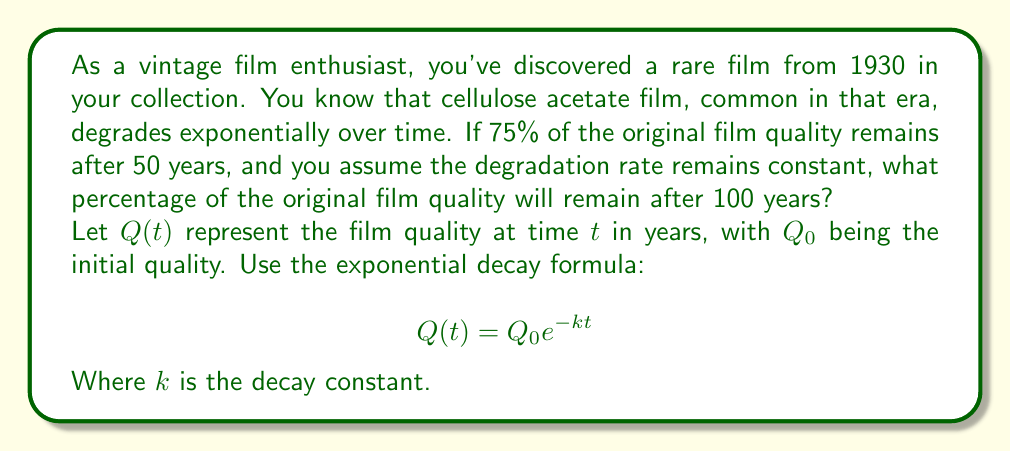Teach me how to tackle this problem. To solve this problem, we'll follow these steps:

1) First, we need to find the decay constant $k$ using the given information:
   After 50 years, 75% of the original quality remains.
   
   $$0.75Q_0 = Q_0 e^{-k(50)}$$

2) Divide both sides by $Q_0$:
   
   $$0.75 = e^{-50k}$$

3) Take the natural logarithm of both sides:
   
   $$\ln(0.75) = -50k$$

4) Solve for $k$:
   
   $$k = -\frac{\ln(0.75)}{50} \approx 0.005755$$

5) Now that we have $k$, we can use the exponential decay formula to find the quality after 100 years:
   
   $$Q(100) = Q_0 e^{-k(100)}$$

6) Substitute $k = 0.005755$:
   
   $$Q(100) = Q_0 e^{-0.005755(100)}$$

7) Simplify:
   
   $$Q(100) = Q_0 e^{-0.5755} \approx 0.5625Q_0$$

8) Convert to a percentage:
   
   $0.5625 * 100\% = 56.25\%$

Therefore, after 100 years, approximately 56.25% of the original film quality will remain.
Answer: 56.25% of the original film quality will remain after 100 years. 